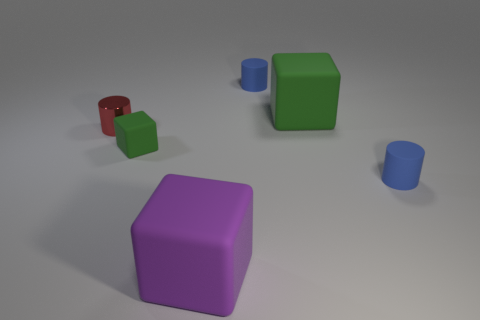Add 1 cylinders. How many objects exist? 7 Subtract all large matte cubes. How many cubes are left? 1 Subtract 0 purple spheres. How many objects are left? 6 Subtract all purple cubes. Subtract all small green things. How many objects are left? 4 Add 5 small blue cylinders. How many small blue cylinders are left? 7 Add 6 big brown matte cubes. How many big brown matte cubes exist? 6 